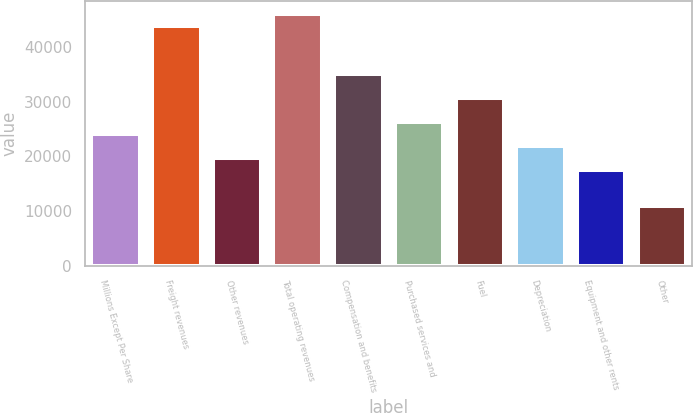Convert chart to OTSL. <chart><loc_0><loc_0><loc_500><loc_500><bar_chart><fcel>Millions Except Per Share<fcel>Freight revenues<fcel>Other revenues<fcel>Total operating revenues<fcel>Compensation and benefits<fcel>Purchased services and<fcel>Fuel<fcel>Depreciation<fcel>Equipment and other rents<fcel>Other<nl><fcel>24159.1<fcel>43924.5<fcel>19766.8<fcel>46120.6<fcel>35139.9<fcel>26355.3<fcel>30747.6<fcel>21963<fcel>17570.7<fcel>10982.2<nl></chart> 